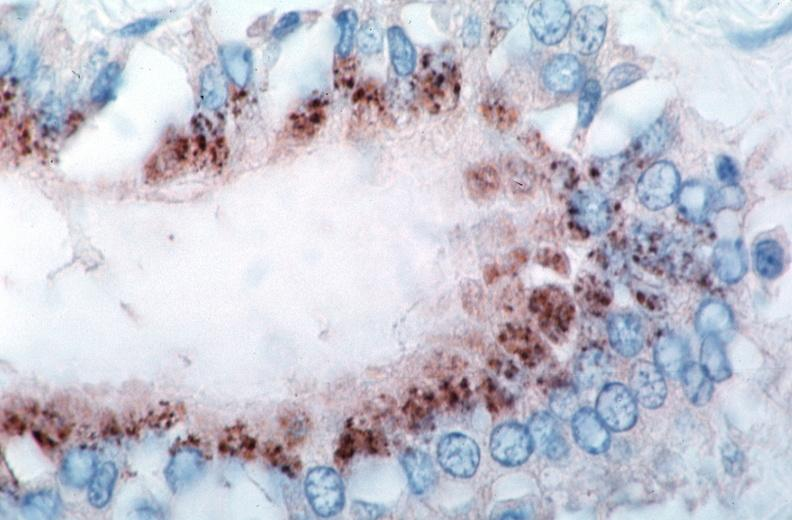s lesion of myocytolysis spotted fever, immunoperoxidase staining vessels for rickettsia rickettsii?
Answer the question using a single word or phrase. No 